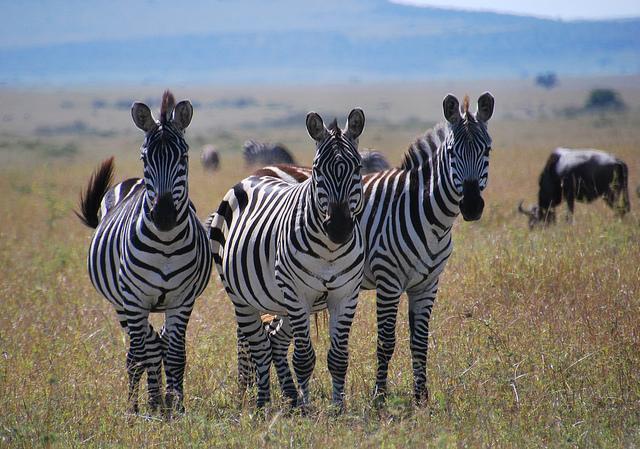How many different types of animals are in the picture?
Give a very brief answer. 2. How many zebras?
Give a very brief answer. 3. How many zebras are facing the camera?
Give a very brief answer. 3. How many zebras are facing forward?
Give a very brief answer. 3. How many animals are in the background?
Give a very brief answer. 4. How many zebras are pictured?
Give a very brief answer. 3. How many zebras are in the picture?
Give a very brief answer. 3. How many people are using a blue umbrella?
Give a very brief answer. 0. 